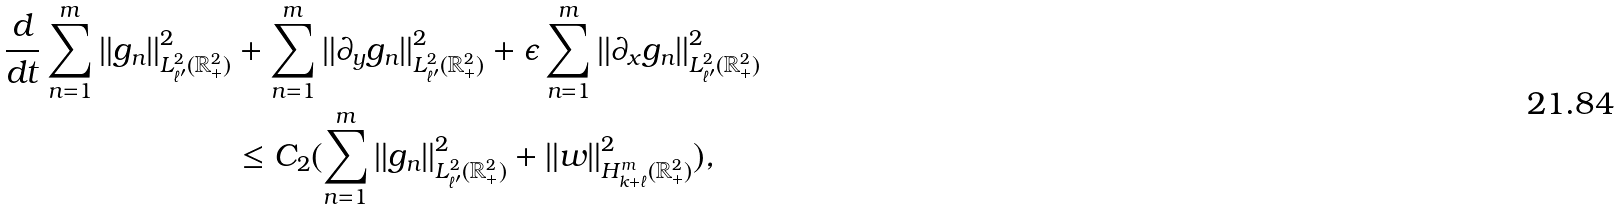Convert formula to latex. <formula><loc_0><loc_0><loc_500><loc_500>\frac { d } { d t } \sum ^ { m } _ { n = 1 } \| g _ { n } \| _ { L ^ { 2 } _ { \ell ^ { \prime } } ( \mathbb { R } ^ { 2 } _ { + } ) } ^ { 2 } & + \sum ^ { m } _ { n = 1 } \| \partial _ { y } g _ { n } \| _ { L ^ { 2 } _ { \ell ^ { \prime } } ( \mathbb { R } ^ { 2 } _ { + } ) } ^ { 2 } + \epsilon \sum ^ { m } _ { n = 1 } \| \partial _ { x } g _ { n } \| _ { L ^ { 2 } _ { \ell ^ { \prime } } ( \mathbb { R } ^ { 2 } _ { + } ) } ^ { 2 } \\ & \leq C _ { 2 } ( \sum ^ { m } _ { n = 1 } \| g _ { n } \| _ { L ^ { 2 } _ { \ell ^ { \prime } } ( \mathbb { R } ^ { 2 } _ { + } ) } ^ { 2 } + \| { w } \| _ { H ^ { m } _ { k + \ell } ( \mathbb { R } ^ { 2 } _ { + } ) } ^ { 2 } ) ,</formula> 